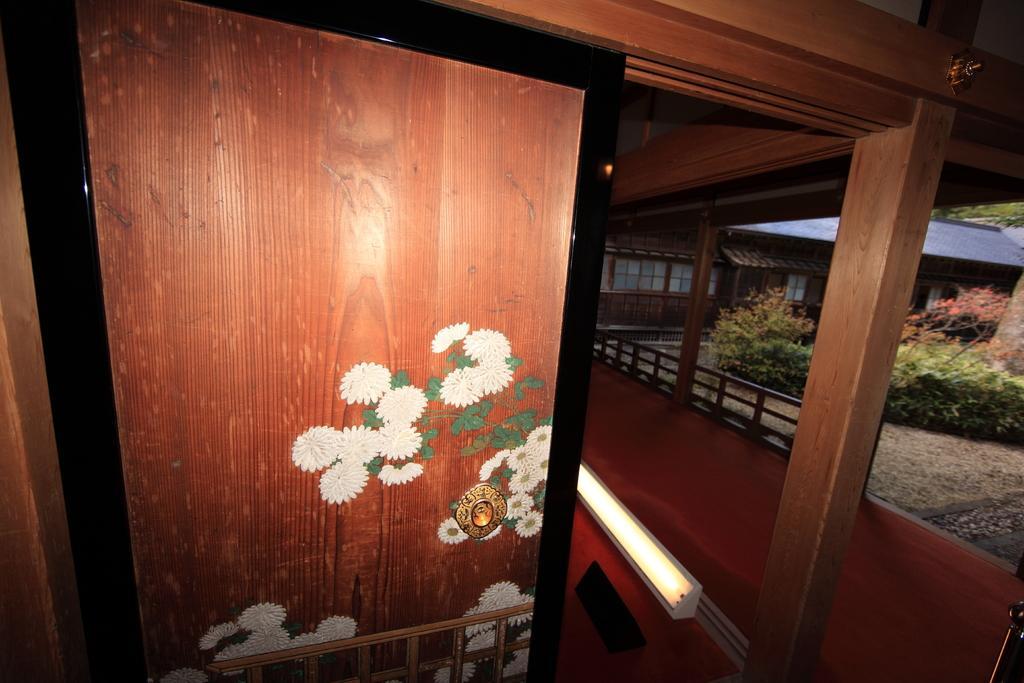Describe this image in one or two sentences. On the left side of the picture there is a door. On the right there is railing. In background towards right there are plants and trees. 